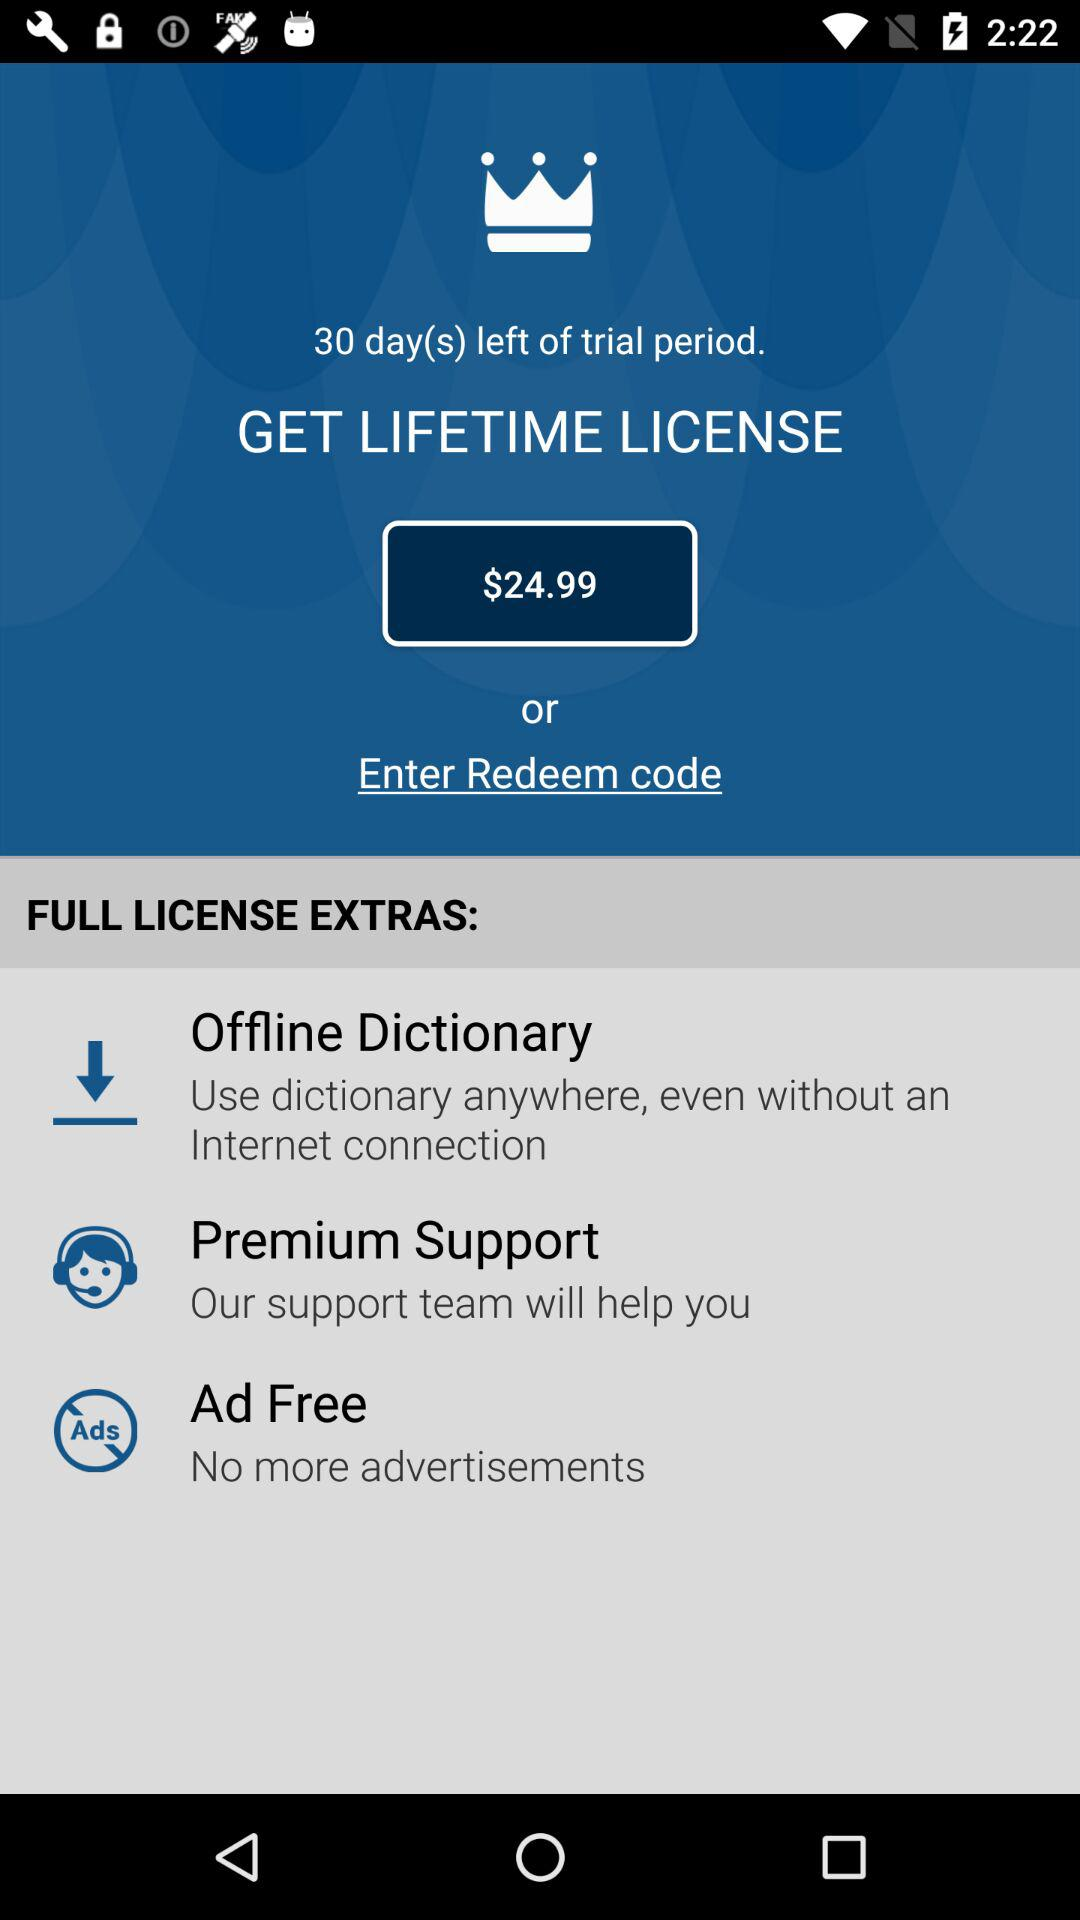How many days are left of the trial period? The number of days left of the trial period is 30. 